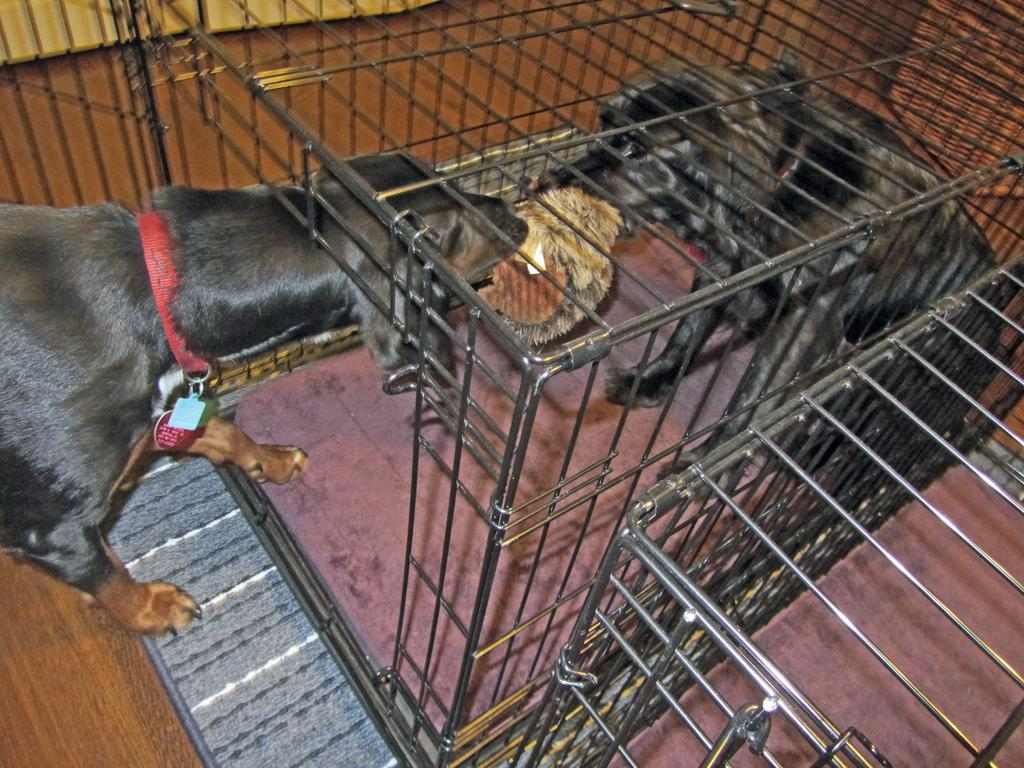How many dogs are present in the image? There are two dogs in the image. What are the dogs doing in the image? The dogs are pulling a doll with their mouths. Where are the dogs located in the image? The dogs are in a cage. How many fingers can be seen on the dogs' paws in the image? Dogs do not have fingers, and there are no fingers visible on the dogs' paws in the image. 